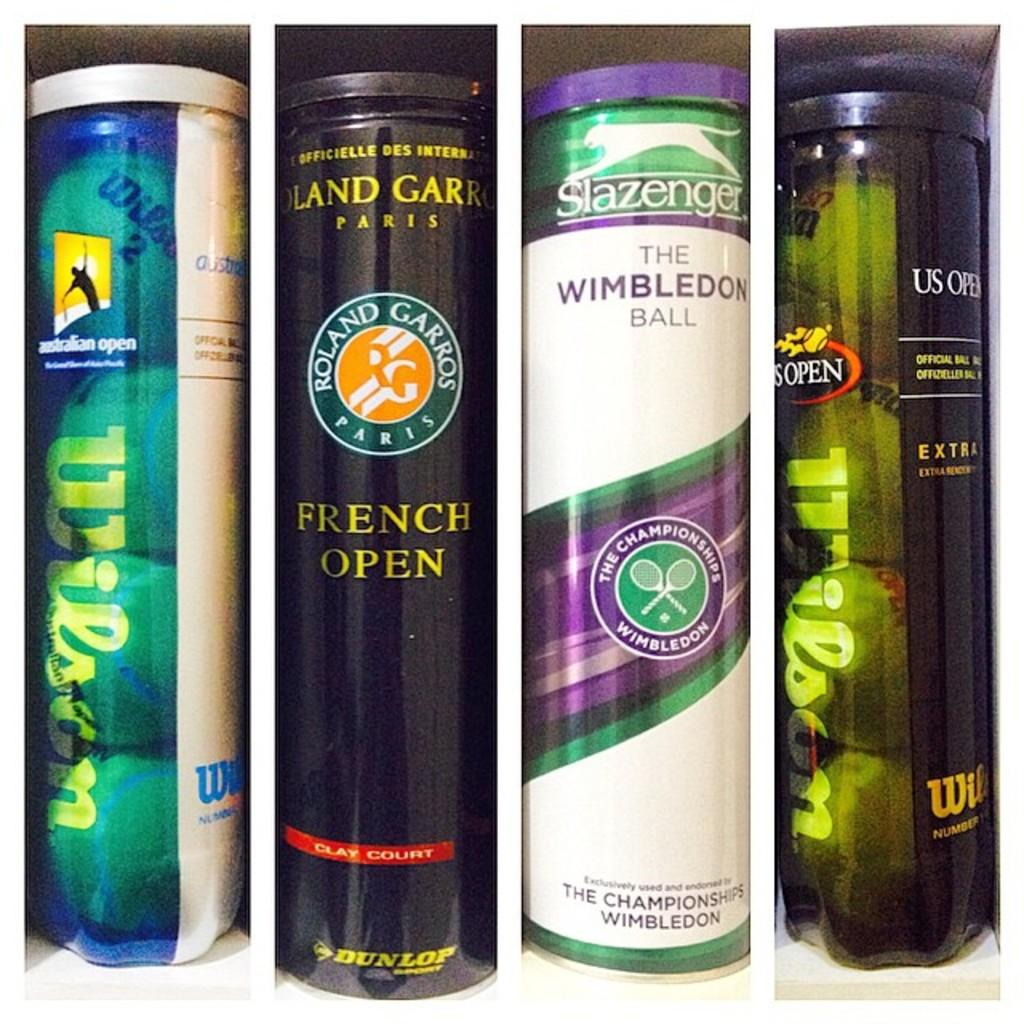<image>
Render a clear and concise summary of the photo. A collection of tennis balls in containers with the brand names Wilson, ROLAND GARROS, and Slazenger is displayed. 